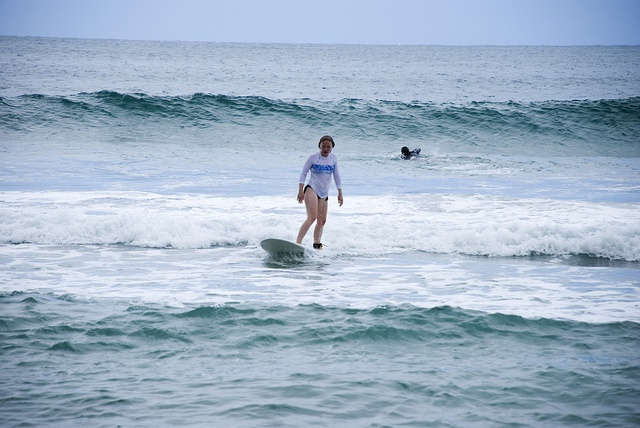Describe the objects in this image and their specific colors. I can see people in gray and darkgray tones, surfboard in gray, purple, darkgray, and black tones, people in gray, black, navy, and darkgray tones, and surfboard in gray, lavender, lightgray, and darkgray tones in this image. 